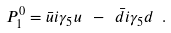<formula> <loc_0><loc_0><loc_500><loc_500>P ^ { 0 } _ { 1 } = \bar { u } i \gamma _ { 5 } u \ - \ \bar { d } i \gamma _ { 5 } d \ .</formula> 